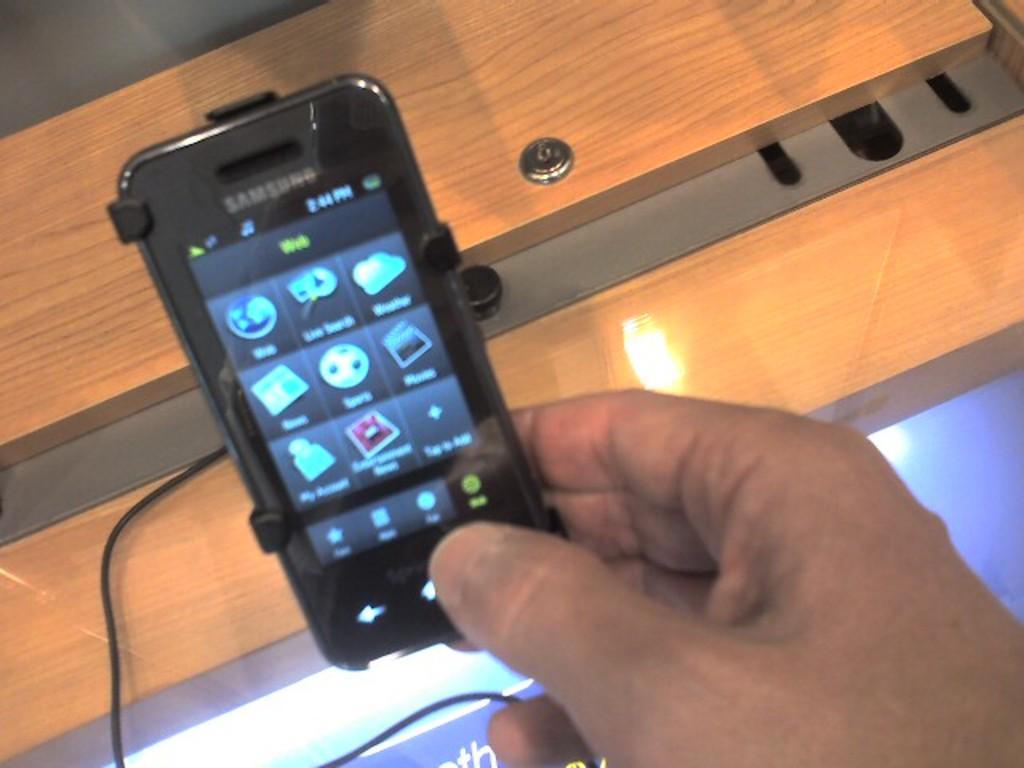Who is the manufacturer of the phone?
Keep it short and to the point. Samsung. 